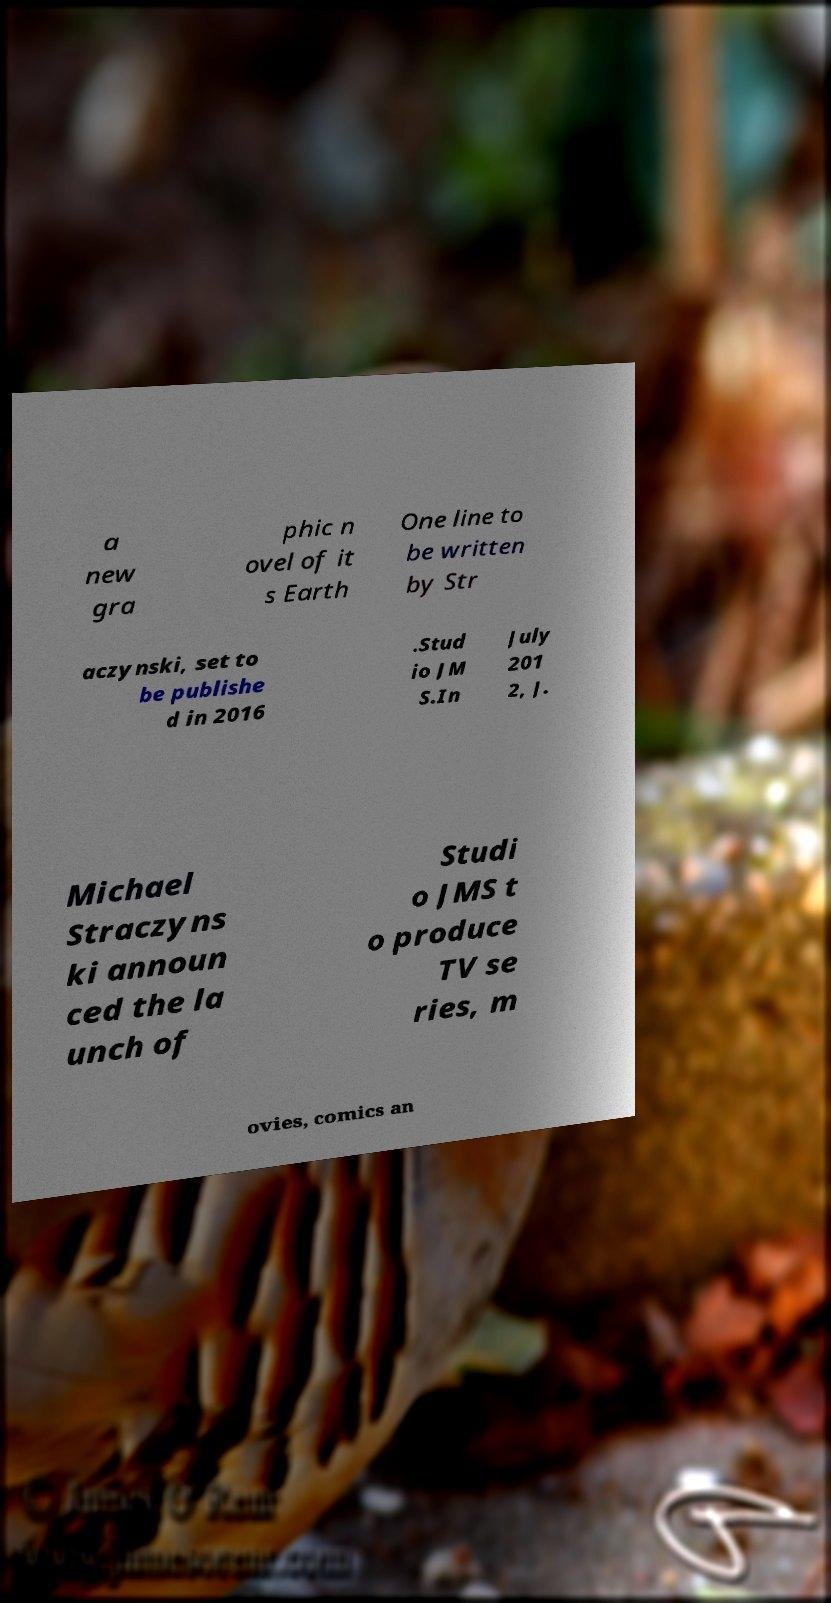Could you extract and type out the text from this image? a new gra phic n ovel of it s Earth One line to be written by Str aczynski, set to be publishe d in 2016 .Stud io JM S.In July 201 2, J. Michael Straczyns ki announ ced the la unch of Studi o JMS t o produce TV se ries, m ovies, comics an 